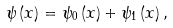<formula> <loc_0><loc_0><loc_500><loc_500>\psi \left ( x \right ) = \psi _ { 0 } \left ( x \right ) + \psi _ { 1 } \left ( x \right ) ,</formula> 